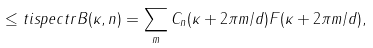Convert formula to latex. <formula><loc_0><loc_0><loc_500><loc_500>\leq t { i s p e c t r } B ( \kappa , n ) = \sum _ { m } C _ { n } ( \kappa + 2 \pi m / d ) F ( \kappa + 2 \pi m / d ) ,</formula> 